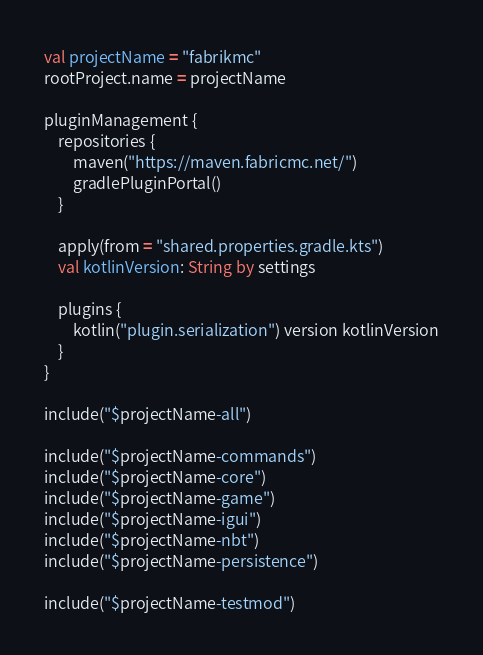<code> <loc_0><loc_0><loc_500><loc_500><_Kotlin_>val projectName = "fabrikmc"
rootProject.name = projectName

pluginManagement {
    repositories {
        maven("https://maven.fabricmc.net/")
        gradlePluginPortal()
    }

    apply(from = "shared.properties.gradle.kts")
    val kotlinVersion: String by settings

    plugins {
        kotlin("plugin.serialization") version kotlinVersion
    }
}

include("$projectName-all")

include("$projectName-commands")
include("$projectName-core")
include("$projectName-game")
include("$projectName-igui")
include("$projectName-nbt")
include("$projectName-persistence")

include("$projectName-testmod")
</code> 